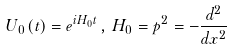Convert formula to latex. <formula><loc_0><loc_0><loc_500><loc_500>U _ { 0 } \left ( t \right ) = e ^ { i H _ { 0 } t } \, , \, H _ { 0 } = p ^ { 2 } = - \frac { d ^ { 2 } } { d x ^ { 2 } }</formula> 